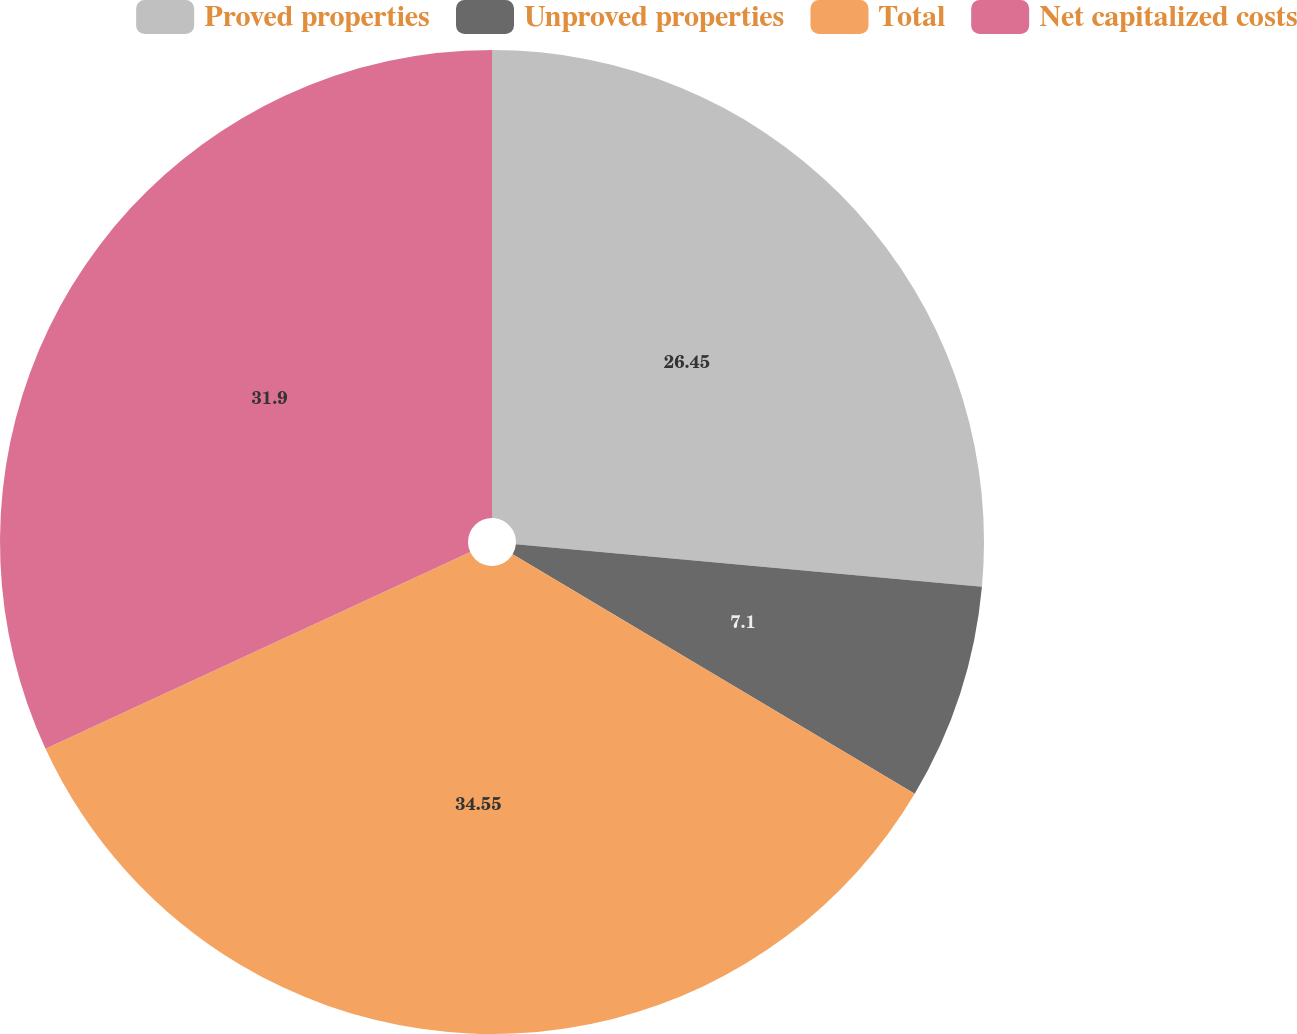<chart> <loc_0><loc_0><loc_500><loc_500><pie_chart><fcel>Proved properties<fcel>Unproved properties<fcel>Total<fcel>Net capitalized costs<nl><fcel>26.45%<fcel>7.1%<fcel>34.55%<fcel>31.9%<nl></chart> 